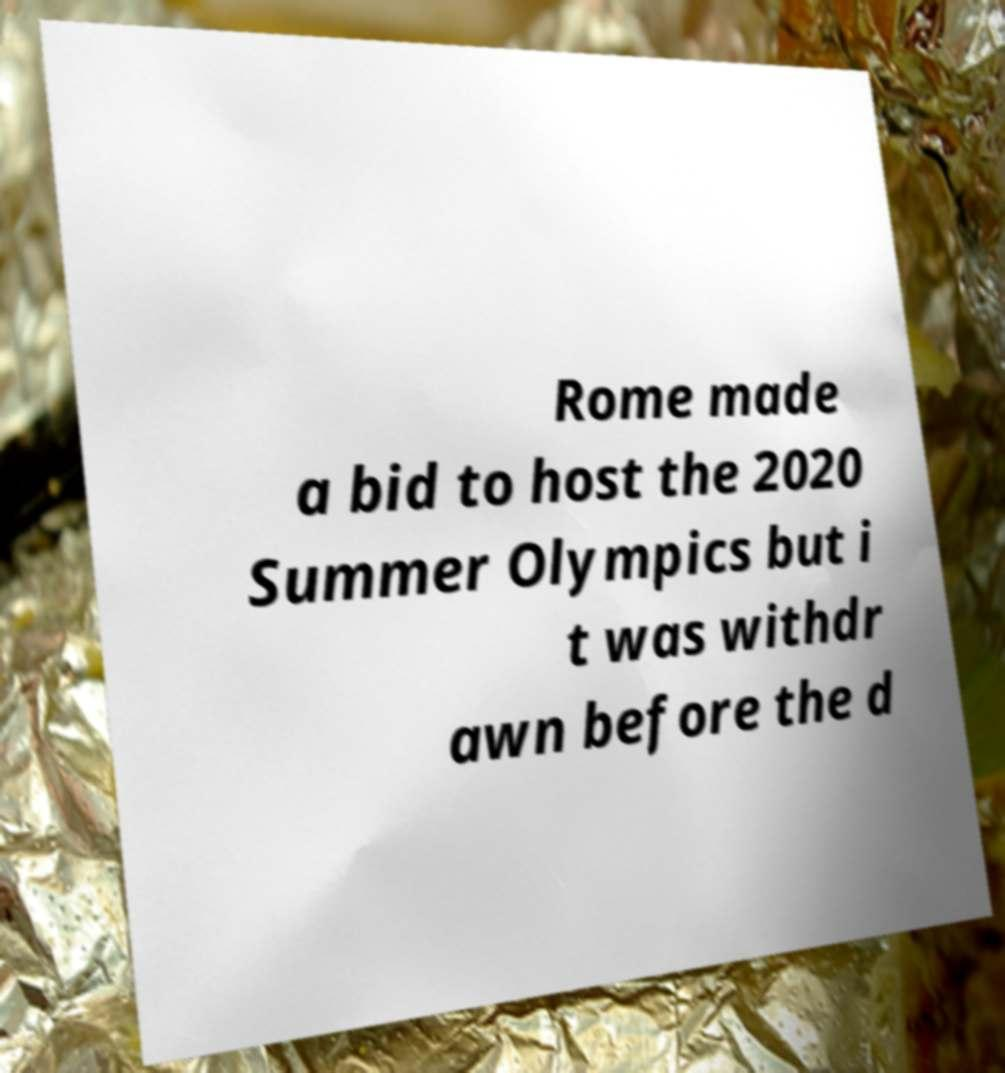I need the written content from this picture converted into text. Can you do that? Rome made a bid to host the 2020 Summer Olympics but i t was withdr awn before the d 